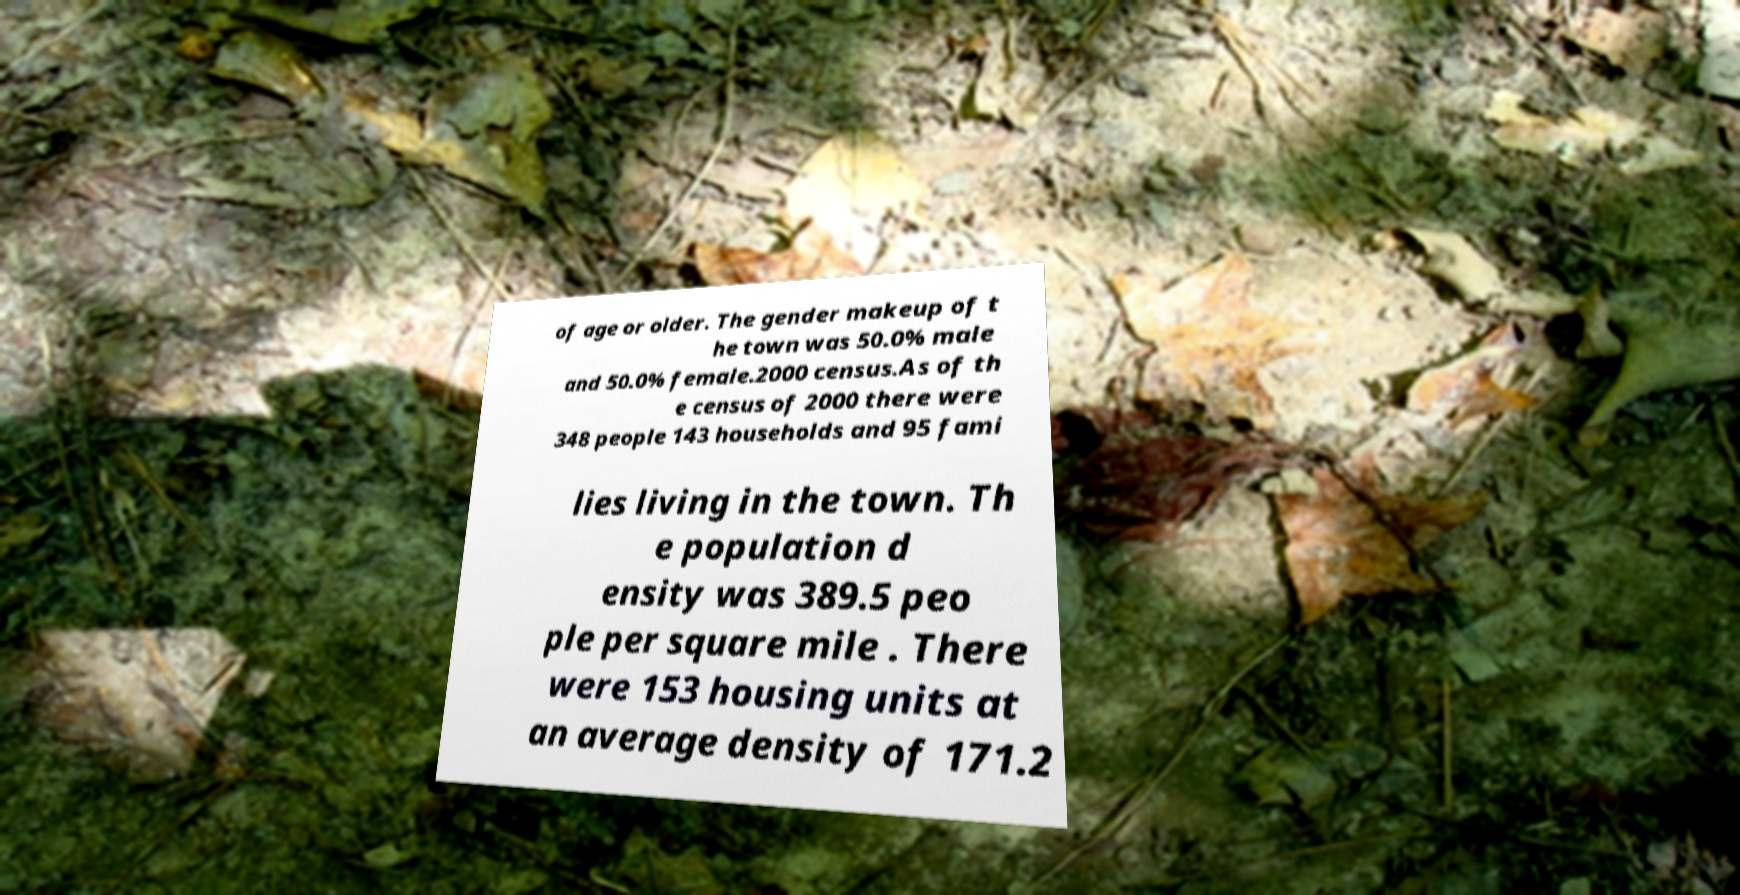What messages or text are displayed in this image? I need them in a readable, typed format. of age or older. The gender makeup of t he town was 50.0% male and 50.0% female.2000 census.As of th e census of 2000 there were 348 people 143 households and 95 fami lies living in the town. Th e population d ensity was 389.5 peo ple per square mile . There were 153 housing units at an average density of 171.2 